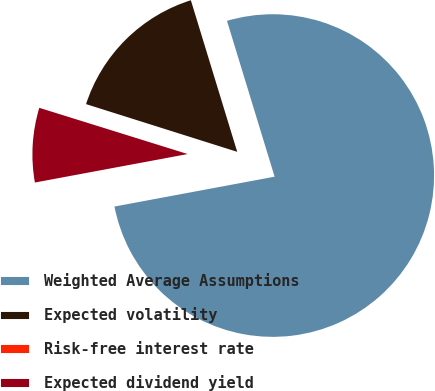Convert chart. <chart><loc_0><loc_0><loc_500><loc_500><pie_chart><fcel>Weighted Average Assumptions<fcel>Expected volatility<fcel>Risk-free interest rate<fcel>Expected dividend yield<nl><fcel>76.79%<fcel>15.41%<fcel>0.06%<fcel>7.74%<nl></chart> 